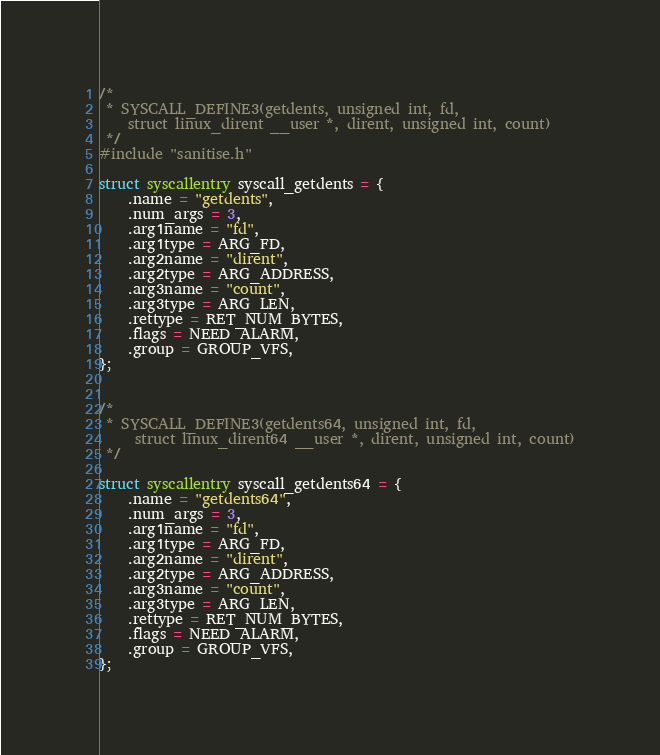<code> <loc_0><loc_0><loc_500><loc_500><_C_>/*
 * SYSCALL_DEFINE3(getdents, unsigned int, fd,
    struct linux_dirent __user *, dirent, unsigned int, count)
 */
#include "sanitise.h"

struct syscallentry syscall_getdents = {
	.name = "getdents",
	.num_args = 3,
	.arg1name = "fd",
	.arg1type = ARG_FD,
	.arg2name = "dirent",
	.arg2type = ARG_ADDRESS,
	.arg3name = "count",
	.arg3type = ARG_LEN,
	.rettype = RET_NUM_BYTES,
	.flags = NEED_ALARM,
	.group = GROUP_VFS,
};


/*
 * SYSCALL_DEFINE3(getdents64, unsigned int, fd,
	 struct linux_dirent64 __user *, dirent, unsigned int, count)
 */

struct syscallentry syscall_getdents64 = {
	.name = "getdents64",
	.num_args = 3,
	.arg1name = "fd",
	.arg1type = ARG_FD,
	.arg2name = "dirent",
	.arg2type = ARG_ADDRESS,
	.arg3name = "count",
	.arg3type = ARG_LEN,
	.rettype = RET_NUM_BYTES,
	.flags = NEED_ALARM,
	.group = GROUP_VFS,
};
</code> 